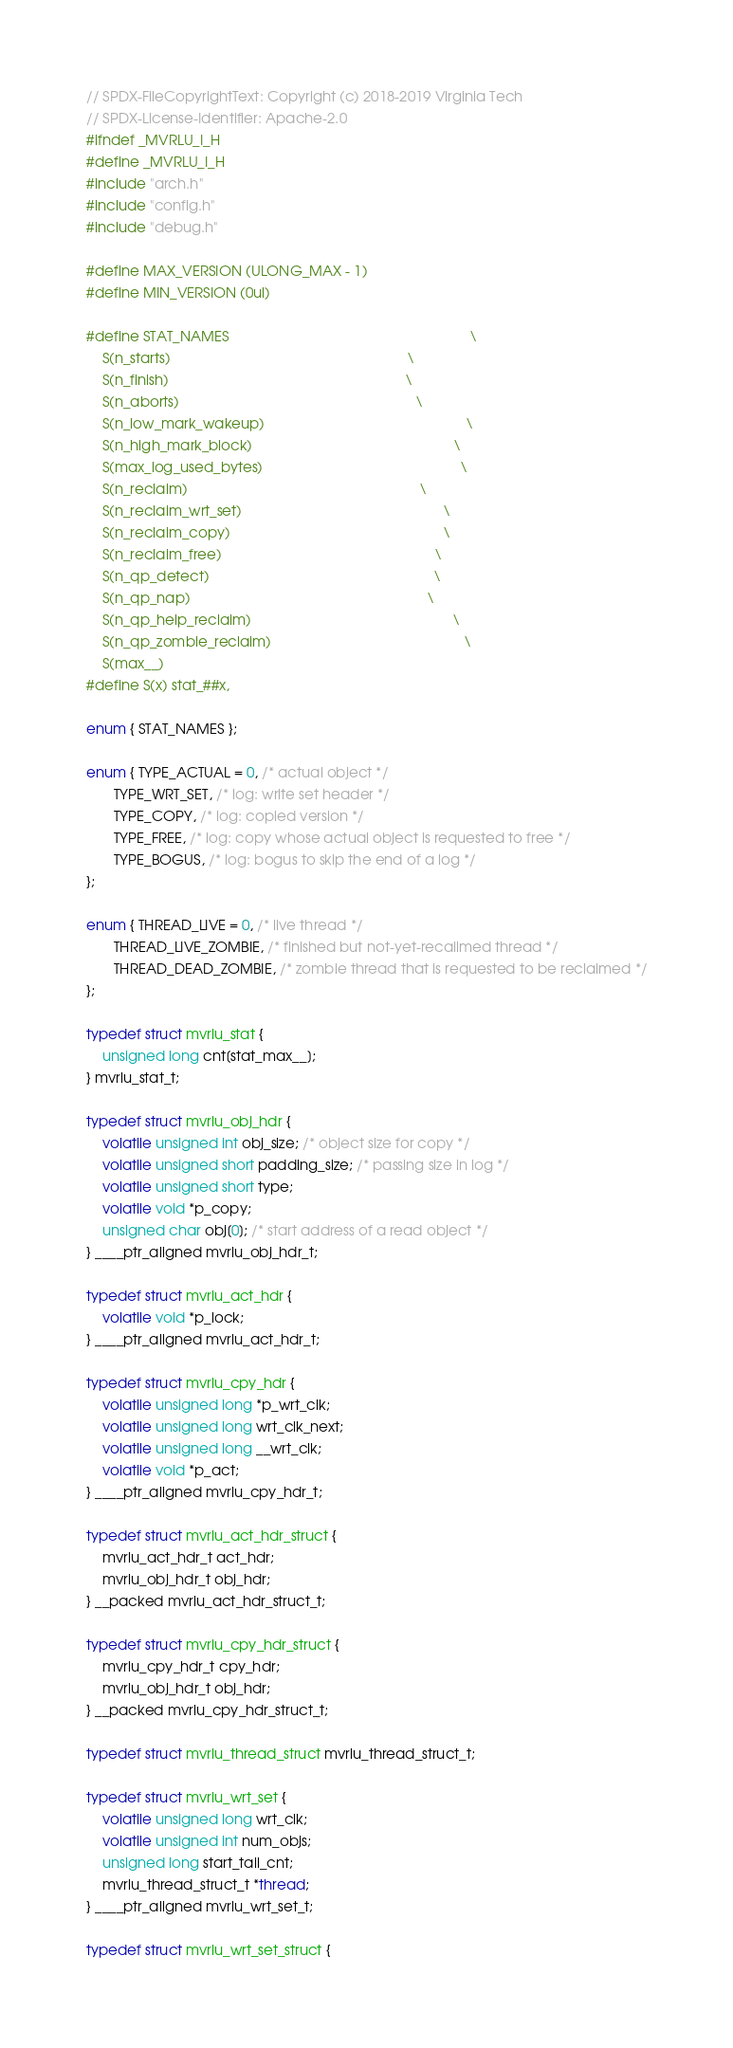Convert code to text. <code><loc_0><loc_0><loc_500><loc_500><_C_>// SPDX-FileCopyrightText: Copyright (c) 2018-2019 Virginia Tech
// SPDX-License-Identifier: Apache-2.0
#ifndef _MVRLU_I_H
#define _MVRLU_I_H
#include "arch.h"
#include "config.h"
#include "debug.h"

#define MAX_VERSION (ULONG_MAX - 1)
#define MIN_VERSION (0ul)

#define STAT_NAMES                                                             \
	S(n_starts)                                                            \
	S(n_finish)                                                            \
	S(n_aborts)                                                            \
	S(n_low_mark_wakeup)                                                   \
	S(n_high_mark_block)                                                   \
	S(max_log_used_bytes)                                                  \
	S(n_reclaim)                                                           \
	S(n_reclaim_wrt_set)                                                   \
	S(n_reclaim_copy)                                                      \
	S(n_reclaim_free)                                                      \
	S(n_qp_detect)                                                         \
	S(n_qp_nap)                                                            \
	S(n_qp_help_reclaim)                                                   \
	S(n_qp_zombie_reclaim)                                                 \
	S(max__)
#define S(x) stat_##x,

enum { STAT_NAMES };

enum { TYPE_ACTUAL = 0, /* actual object */
       TYPE_WRT_SET, /* log: write set header */
       TYPE_COPY, /* log: copied version */
       TYPE_FREE, /* log: copy whose actual object is requested to free */
       TYPE_BOGUS, /* log: bogus to skip the end of a log */
};

enum { THREAD_LIVE = 0, /* live thread */
       THREAD_LIVE_ZOMBIE, /* finished but not-yet-recalimed thread */
       THREAD_DEAD_ZOMBIE, /* zombie thread that is requested to be reclaimed */
};

typedef struct mvrlu_stat {
	unsigned long cnt[stat_max__];
} mvrlu_stat_t;

typedef struct mvrlu_obj_hdr {
	volatile unsigned int obj_size; /* object size for copy */
	volatile unsigned short padding_size; /* passing size in log */
	volatile unsigned short type;
	volatile void *p_copy;
	unsigned char obj[0]; /* start address of a read object */
} ____ptr_aligned mvrlu_obj_hdr_t;

typedef struct mvrlu_act_hdr {
	volatile void *p_lock;
} ____ptr_aligned mvrlu_act_hdr_t;

typedef struct mvrlu_cpy_hdr {
	volatile unsigned long *p_wrt_clk;
	volatile unsigned long wrt_clk_next;
	volatile unsigned long __wrt_clk;
	volatile void *p_act;
} ____ptr_aligned mvrlu_cpy_hdr_t;

typedef struct mvrlu_act_hdr_struct {
	mvrlu_act_hdr_t act_hdr;
	mvrlu_obj_hdr_t obj_hdr;
} __packed mvrlu_act_hdr_struct_t;

typedef struct mvrlu_cpy_hdr_struct {
	mvrlu_cpy_hdr_t cpy_hdr;
	mvrlu_obj_hdr_t obj_hdr;
} __packed mvrlu_cpy_hdr_struct_t;

typedef struct mvrlu_thread_struct mvrlu_thread_struct_t;

typedef struct mvrlu_wrt_set {
	volatile unsigned long wrt_clk;
	volatile unsigned int num_objs;
	unsigned long start_tail_cnt;
	mvrlu_thread_struct_t *thread;
} ____ptr_aligned mvrlu_wrt_set_t;

typedef struct mvrlu_wrt_set_struct {</code> 